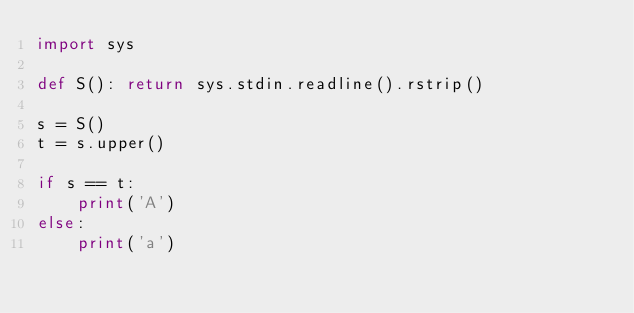Convert code to text. <code><loc_0><loc_0><loc_500><loc_500><_Python_>import sys

def S(): return sys.stdin.readline().rstrip()

s = S()
t = s.upper()

if s == t:
    print('A')
else:
    print('a')</code> 